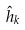Convert formula to latex. <formula><loc_0><loc_0><loc_500><loc_500>\hat { h } _ { k }</formula> 